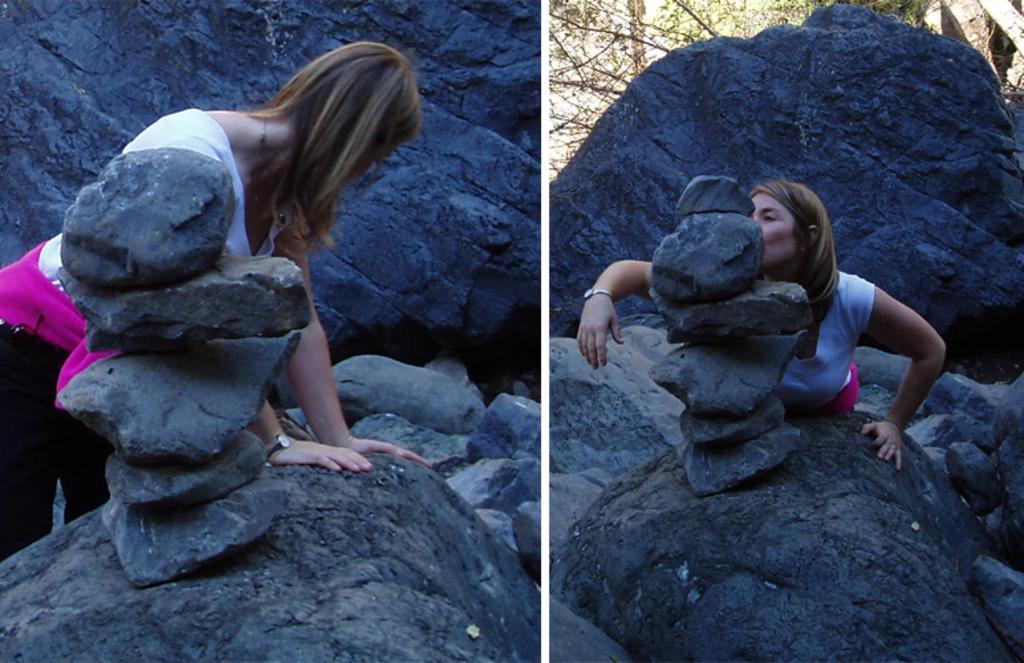Can you describe this image briefly? It is the collage of two images. In the image, which is on the left side we can see that there is a girl standing by keeping her hands on the stone. In front of her there are stones which are kept one above the other. In the image which is on the right side there is a girl who is kissing the stones. In the background there is a big rock. Behind the rock there are trees. 